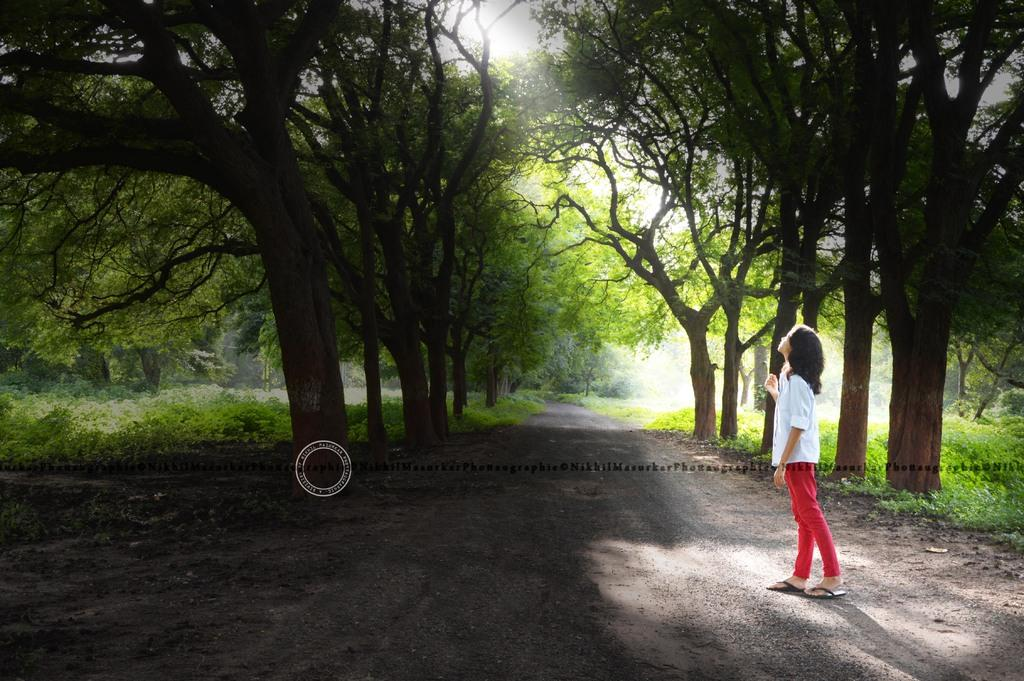Who is the main subject in the image? There is a girl in the image. Where is the girl located in relation to the road? The girl is standing between the road. What type of vegetation is present on either side of the road? There are trees on either side of the road. What type of ground surface is visible in the image? There is grass visible in the image. What is the girl's opinion on the box in the image? There is no box present in the image, so it is not possible to determine the girl's opinion on it. 